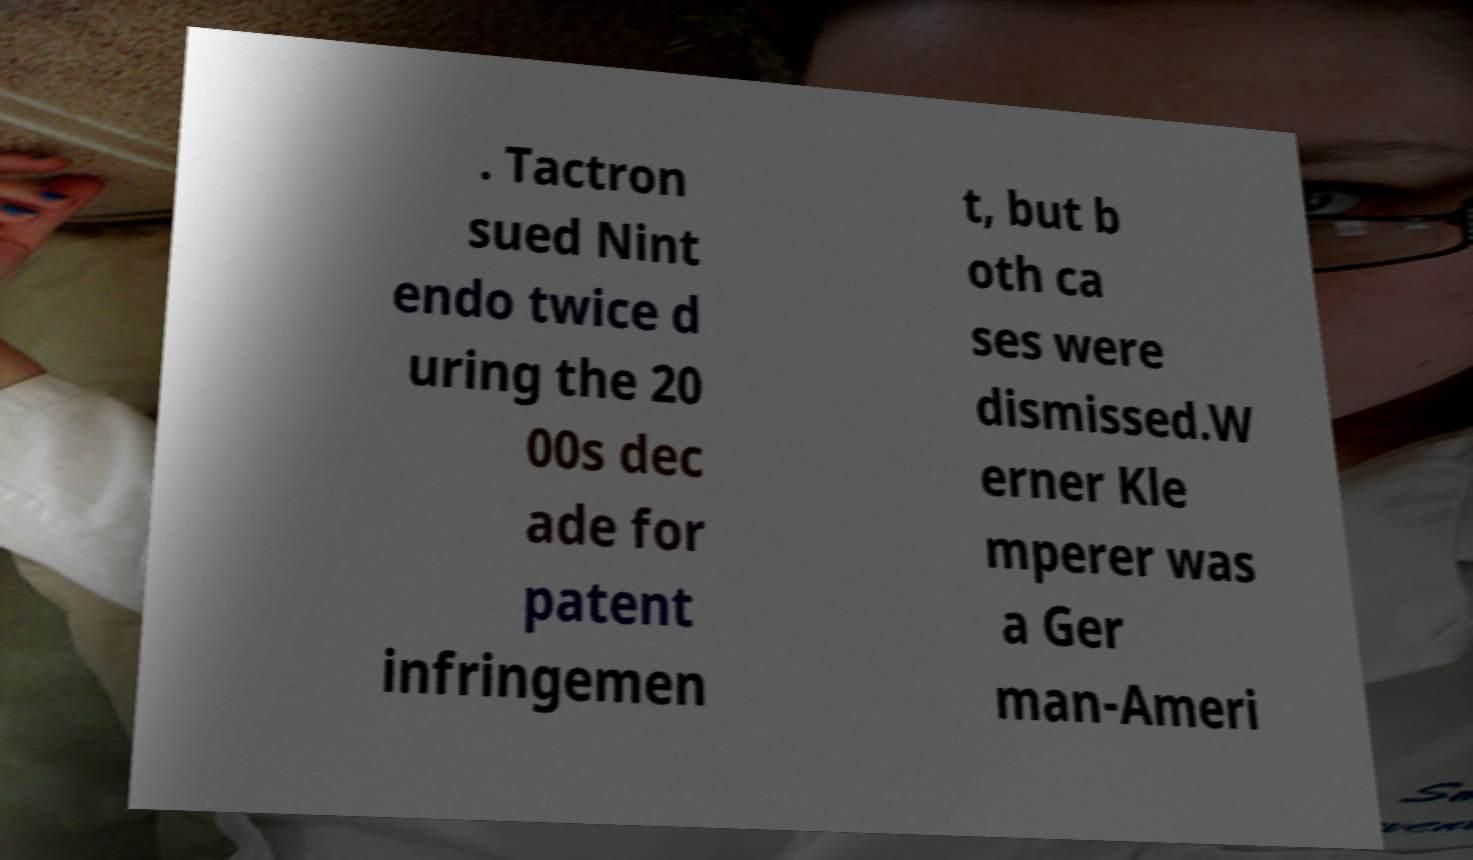Can you accurately transcribe the text from the provided image for me? . Tactron sued Nint endo twice d uring the 20 00s dec ade for patent infringemen t, but b oth ca ses were dismissed.W erner Kle mperer was a Ger man-Ameri 